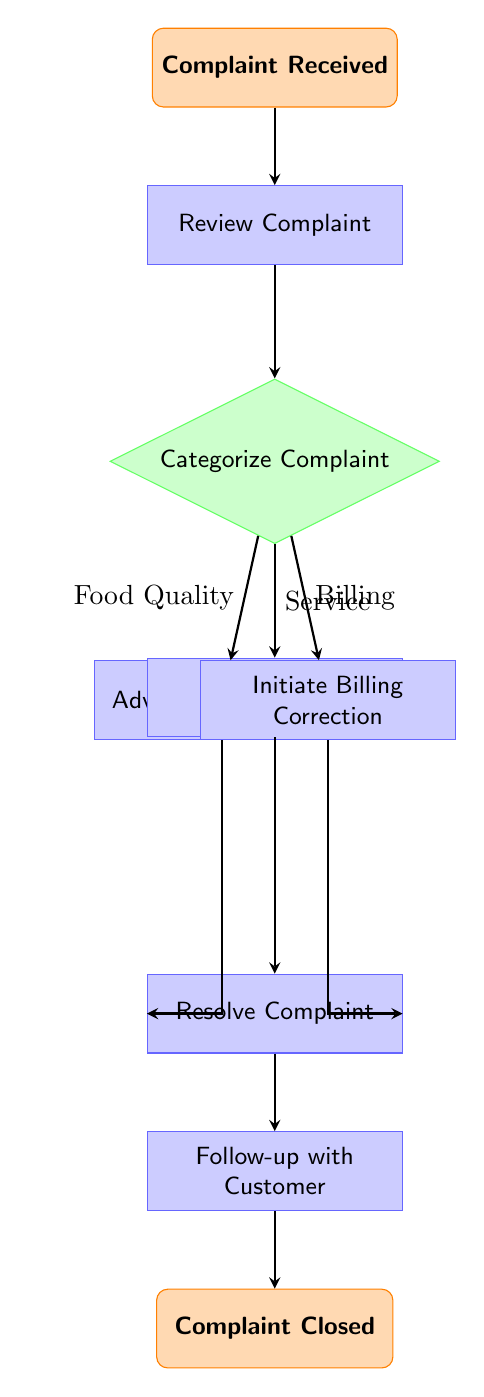What is the first action taken after a complaint is received? The flow chart begins with the "Complaint Received" node, indicating that this is the starting point. The next action in the workflow is "Review Complaint".
Answer: Review Complaint How many different categories of complaints are there? The diagram shows three categories in the "Categorize Complaint" decision node: Food Quality Issue, Service Issue, and Billing Issue. Therefore, there are three categories.
Answer: Three What happens if a complaint is categorized as a Food Quality Issue? If a complaint is categorized as a Food Quality Issue, the next step to follow is "Advise Kitchen Staff". This is indicated by the arrow pointing from the Food Quality Issue option to the Advise Kitchen Staff node.
Answer: Advise Kitchen Staff What is the last step in the complaint resolution process? The last node in the flow chart is "Complaint Closed", which indicates the end of the workflow when all actions have been completed.
Answer: Complaint Closed How many processes are there in total in this workflow? The processes are represented by the nodes: "Review Complaint", "Advise Kitchen Staff", "Notify Service Manager", "Initiate Billing Correction", "Resolve Complaint", and "Follow-up with Customer". Counting these gives a total of six processes.
Answer: Six Which step comes after notifying the Service Manager? After the "Notify Service Manager" node, the next step in the workflow is "Resolve Complaint," as indicated by the arrow that connects these two processes.
Answer: Resolve Complaint What are the three types of complaints categorized in the decision node? The decision node lists three types of complaints: Food Quality Issue, Service Issue, and Billing Issue, which are all options leading to different processes.
Answer: Food Quality Issue, Service Issue, Billing Issue Which node directly follows the complaint resolution process? The node that directly follows "Resolve Complaint" is "Follow-up with Customer", as shown by the arrow leading from the Resolve Complaint node to the Follow-up with Customer node.
Answer: Follow-up with Customer What is the purpose of the "Review Complaint" process? The "Review Complaint" process serves the role of evaluating the received complaint to determine how to categorize it, which is the next step in the workflow.
Answer: Evaluate the complaint 